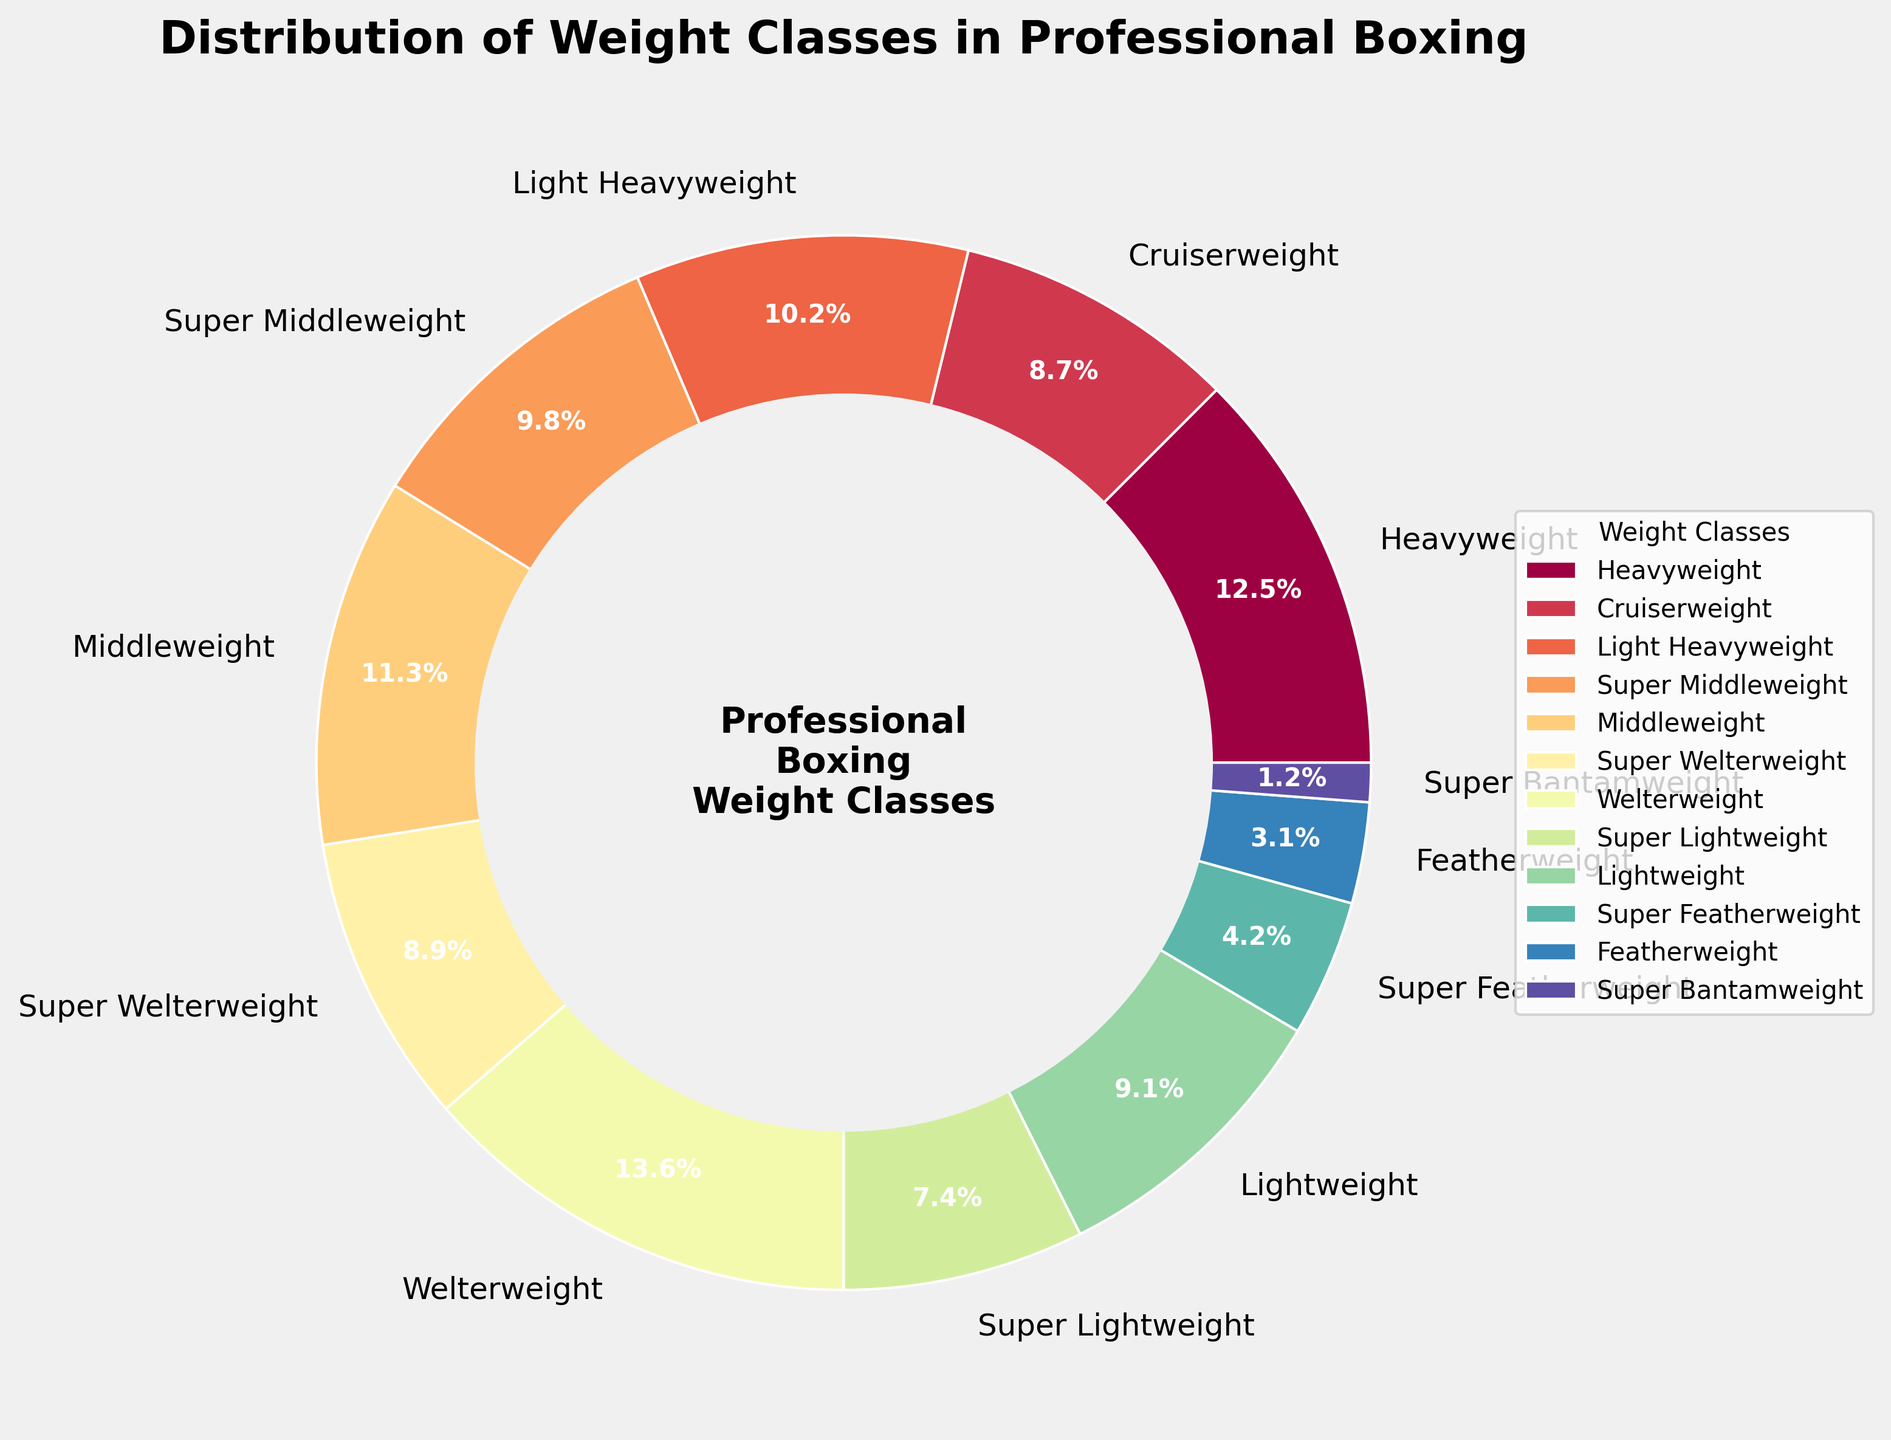What weight class has the highest percentage among professional boxers? The figure shows that the Welterweight class has the largest wedge, indicating the highest percentage of 13.6%.
Answer: Welterweight What is the combined percentage of the Light Heavyweight, Middleweight, and Super Middleweight classes? Adding the percentages of these classes gives 10.2% + 11.3% + 9.8% = 31.3%.
Answer: 31.3% Are there more Heavyweight boxers or Cruiserweight boxers according to the chart? The Heavyweight class has a percentage of 12.5%, while Cruiserweight has 8.7%. Since 12.5% is higher than 8.7%, there are more Heavyweight boxers.
Answer: Heavyweight Which weight class has the lowest percentage, and what is that percentage? The Super Bantamweight class has the smallest wedge in the chart, showing a percentage of 1.2%.
Answer: Super Bantamweight What is the difference in percentage between the Welterweight and the Super Featherweight classes? The Welterweight class has 13.6%, and the Super Featherweight class has 4.2%. The difference is 13.6% - 4.2% = 9.4%.
Answer: 9.4% How many weight classes have a percentage greater than 10%? According to the chart, there are three weight classes with percentages greater than 10%: Heavyweight (12.5%), Light Heavyweight (10.2%), and Welterweight (13.6%).
Answer: 3 If you combine Lightweight and Featherweight, what percentage do they represent together? Adding the percentages of Lightweight (9.1%) and Featherweight (3.1%) gives 9.1% + 3.1% = 12.2%.
Answer: 12.2% Which weight class appears to have the closest percentage to 10%? The Super Middleweight class has a percentage of 9.8%, which is closest to 10% among all the classes.
Answer: Super Middleweight List the weight classes that have a percentage less than 5%. The chart indicates that Super Featherweight (4.2%), Featherweight (3.1%), and Super Bantamweight (1.2%) have percentages less than 5%.
Answer: Super Featherweight, Featherweight, Super Bantamweight 